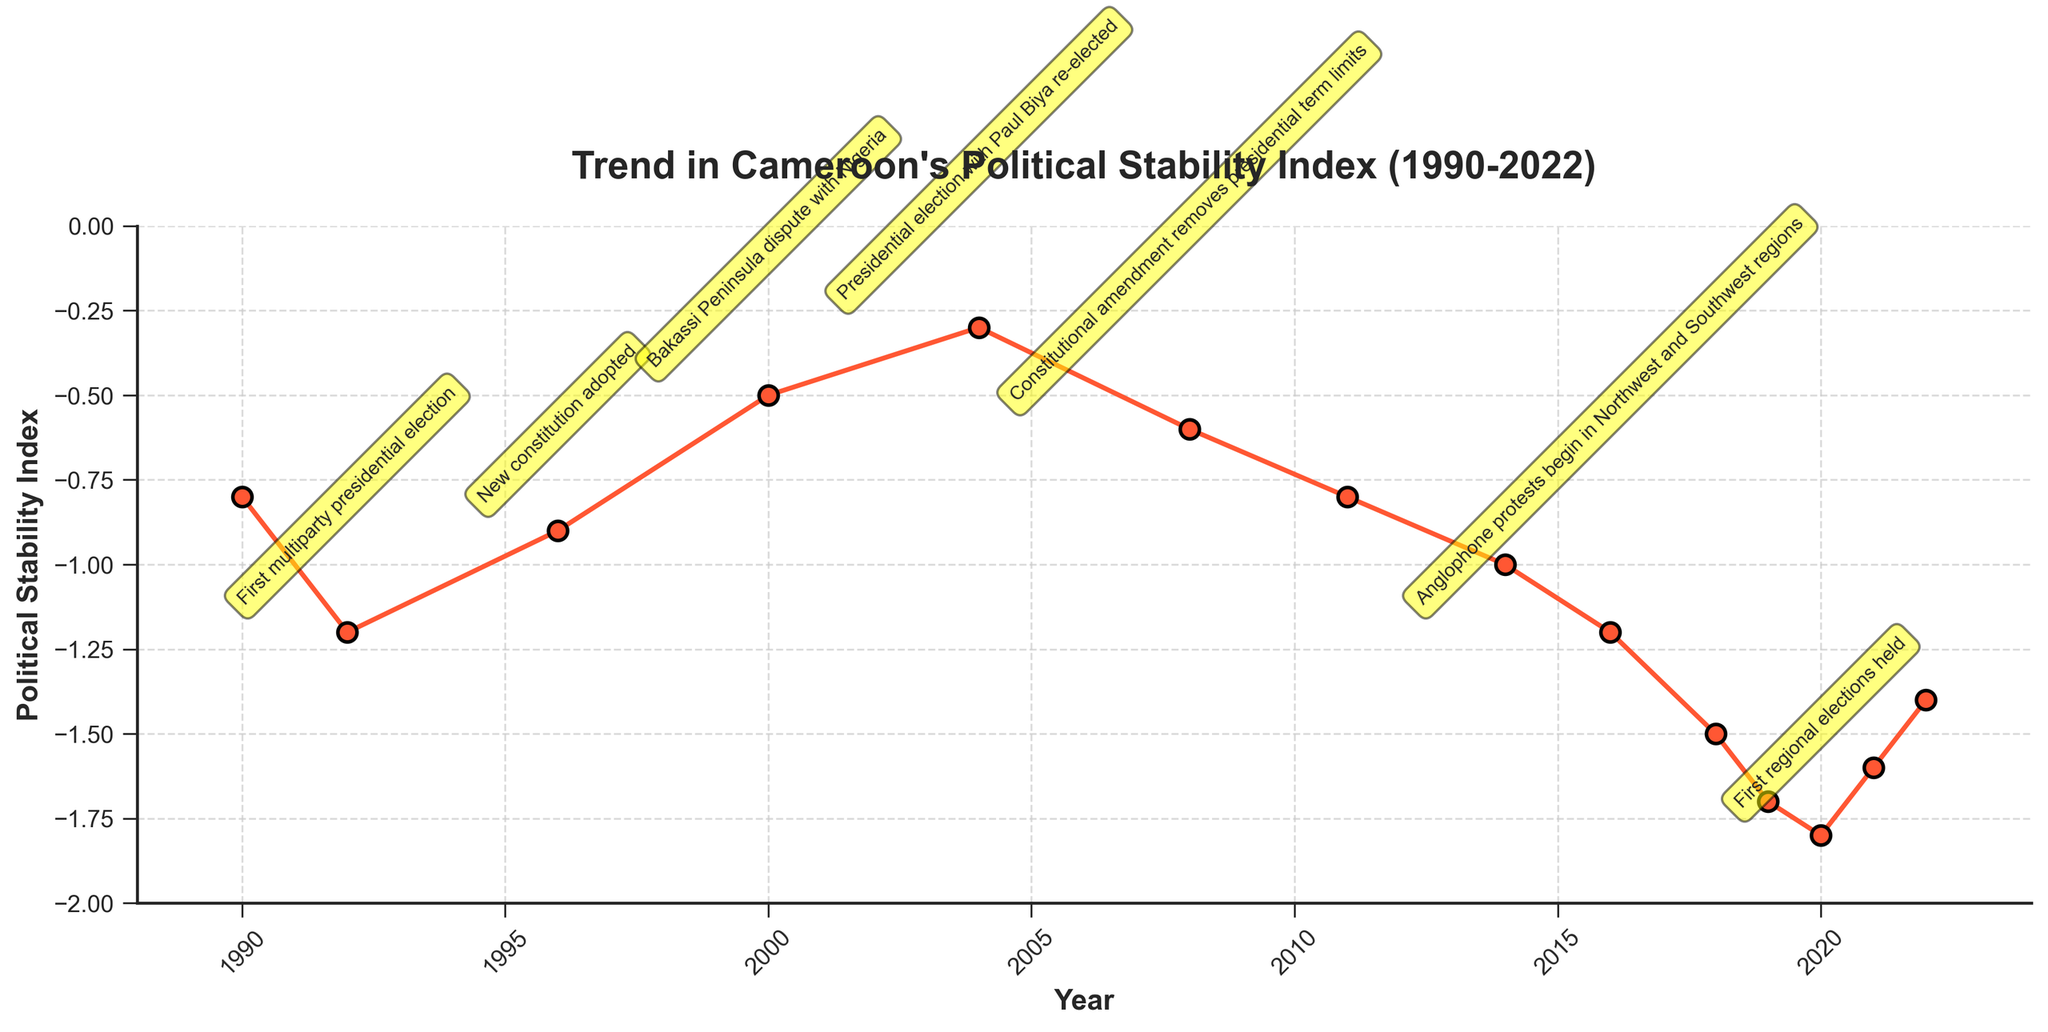What year saw the lowest Political Stability Index? We need to identify the year with the lowest point on the line chart. The lowest index value is -1.8 in 2020.
Answer: 2020 How did the Political Stability Index change from 1990 to 1992? Check the Stability Index at 1990 and 1992; it went from -0.8 to -1.2. Therefore, the change is -1.2 - (-0.8) = -0.4, indicating a decrease.
Answer: Decreased by 0.4 Which year marks the beginning of a continuous decline in the Political Stability Index starting from 2016? Observing the chart from 2016, the index continuously declines from -1.2 in 2016 to -1.8 in 2020. So, the trend begins in 2016.
Answer: 2016 What is the trend of the Political Stability Index before and after the 2008 Constitutional amendment removing presidential term limits? Before 2008, the index fluctuates but shows an overall improvement moving closer to 0. After the amendment in 2008, it declines to -0.6, -0.8 in 2011, and continues declining further.
Answer: Improved before 2008, then declined Compare the Political Stability Index between the first multiparty presidential election and the adoption of the new constitution. Look at the index in 1992 and 1996; it went from -1.2 in 1992 to -0.9 in 1996. The index improved by -0.9 - (-1.2) = 0.3.
Answer: Improved by 0.3 By how much did the Political Stability Index improve from 2004 to 2008? Examine 2004 and 2008 values where the index went from -0.3 to -0.6. So, the change is -0.6 - (-0.3) = -0.3, a decrease. Hence, it did not improve.
Answer: Did not improve, it decreased by 0.3 Does the Political Stability Index show a positive or negative trend from 2011 to 2022? Between these years, the index moves from -0.8 in 2011 to -1.4 in 2022. The general trend is downward which is negative.
Answer: Negative trend What visual marker indicates the key events on the chart? The chart uses annotations with highlighted boxes near specific data points to mark key events. These are visually noticeable as yellow rounded boxes.
Answer: Yellow rounded boxes Between the Bakassi Peninsula dispute in 2000 and the Anglophone protests in 2016, did the stability index ever fall below -1.0? Review the values from 2000 to 2016. The lowest point during this period is -0.8 in 2011, which is still above -1.0.
Answer: No 